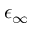Convert formula to latex. <formula><loc_0><loc_0><loc_500><loc_500>\epsilon _ { \infty }</formula> 